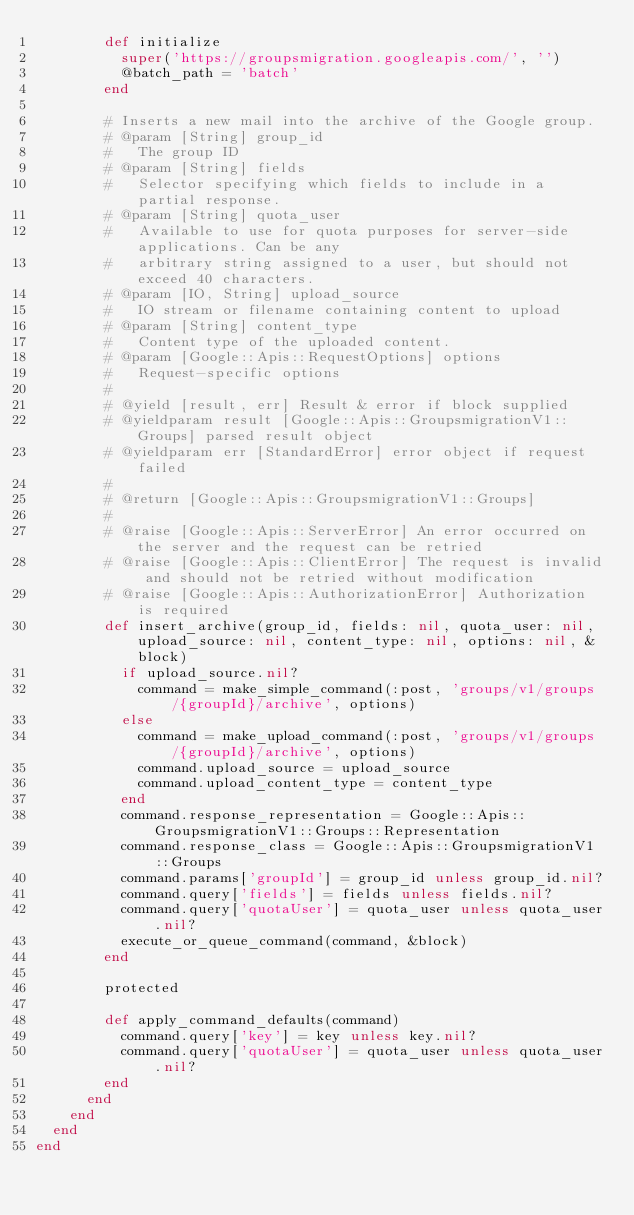<code> <loc_0><loc_0><loc_500><loc_500><_Ruby_>        def initialize
          super('https://groupsmigration.googleapis.com/', '')
          @batch_path = 'batch'
        end
        
        # Inserts a new mail into the archive of the Google group.
        # @param [String] group_id
        #   The group ID
        # @param [String] fields
        #   Selector specifying which fields to include in a partial response.
        # @param [String] quota_user
        #   Available to use for quota purposes for server-side applications. Can be any
        #   arbitrary string assigned to a user, but should not exceed 40 characters.
        # @param [IO, String] upload_source
        #   IO stream or filename containing content to upload
        # @param [String] content_type
        #   Content type of the uploaded content.
        # @param [Google::Apis::RequestOptions] options
        #   Request-specific options
        #
        # @yield [result, err] Result & error if block supplied
        # @yieldparam result [Google::Apis::GroupsmigrationV1::Groups] parsed result object
        # @yieldparam err [StandardError] error object if request failed
        #
        # @return [Google::Apis::GroupsmigrationV1::Groups]
        #
        # @raise [Google::Apis::ServerError] An error occurred on the server and the request can be retried
        # @raise [Google::Apis::ClientError] The request is invalid and should not be retried without modification
        # @raise [Google::Apis::AuthorizationError] Authorization is required
        def insert_archive(group_id, fields: nil, quota_user: nil, upload_source: nil, content_type: nil, options: nil, &block)
          if upload_source.nil?
            command = make_simple_command(:post, 'groups/v1/groups/{groupId}/archive', options)
          else
            command = make_upload_command(:post, 'groups/v1/groups/{groupId}/archive', options)
            command.upload_source = upload_source
            command.upload_content_type = content_type
          end
          command.response_representation = Google::Apis::GroupsmigrationV1::Groups::Representation
          command.response_class = Google::Apis::GroupsmigrationV1::Groups
          command.params['groupId'] = group_id unless group_id.nil?
          command.query['fields'] = fields unless fields.nil?
          command.query['quotaUser'] = quota_user unless quota_user.nil?
          execute_or_queue_command(command, &block)
        end

        protected

        def apply_command_defaults(command)
          command.query['key'] = key unless key.nil?
          command.query['quotaUser'] = quota_user unless quota_user.nil?
        end
      end
    end
  end
end
</code> 